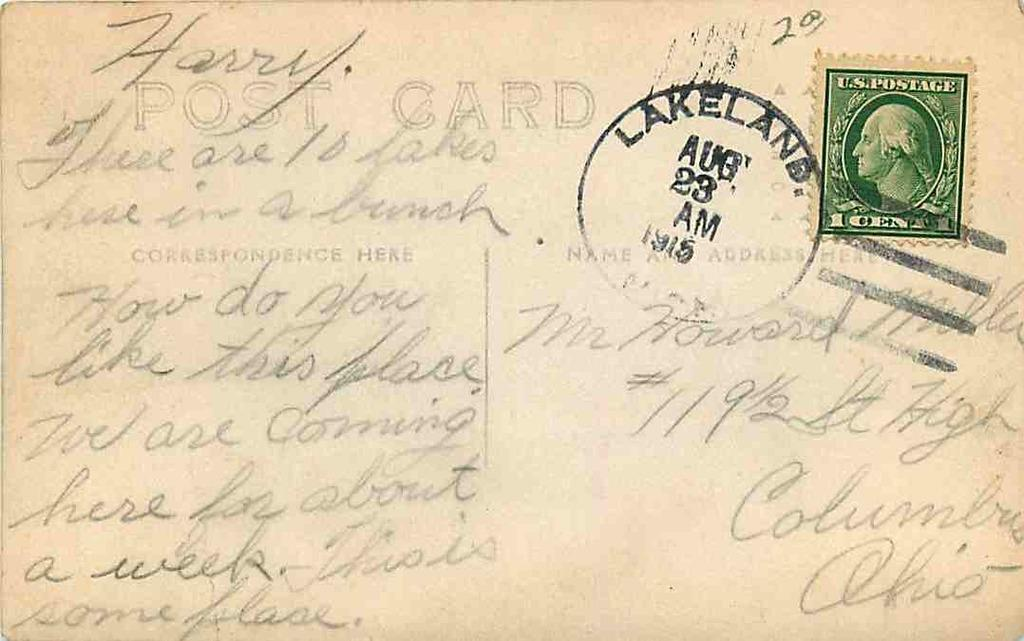<image>
Give a short and clear explanation of the subsequent image. A postcard written to Harry around August 1915. 